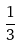Convert formula to latex. <formula><loc_0><loc_0><loc_500><loc_500>\frac { 1 } { 3 }</formula> 